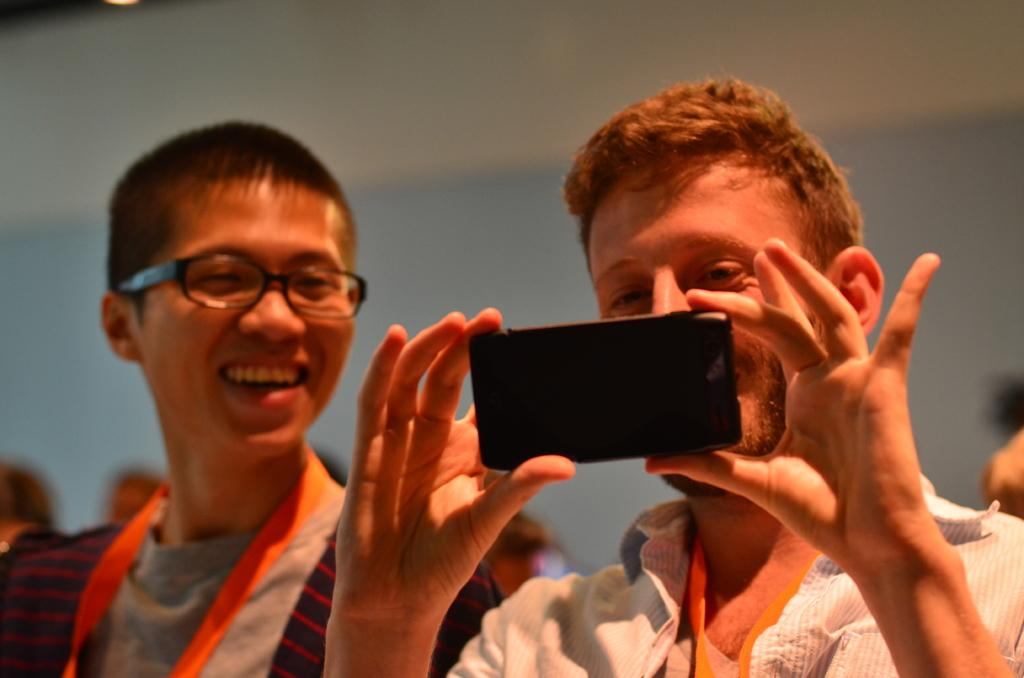How many people are in the image? There are multiple persons in the image. What is one person doing with a device in the image? One person is holding a mobile in the image. Can you describe any accessories worn by the persons in the image? One person is wearing glasses in the image. What can be seen in the background of the image? There is a wall visible in the background of the image. How many visitors are present in the image? There is no mention of visitors in the image; it only shows multiple persons. What type of curtain can be seen hanging from the wall in the image? There is no curtain visible in the image; only a wall is mentioned in the background. 